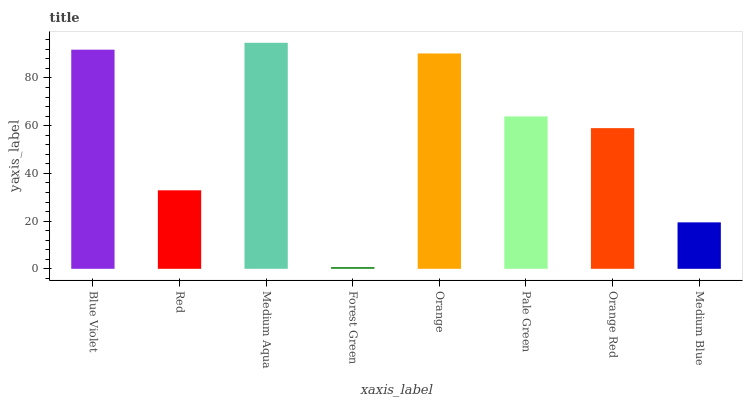Is Forest Green the minimum?
Answer yes or no. Yes. Is Medium Aqua the maximum?
Answer yes or no. Yes. Is Red the minimum?
Answer yes or no. No. Is Red the maximum?
Answer yes or no. No. Is Blue Violet greater than Red?
Answer yes or no. Yes. Is Red less than Blue Violet?
Answer yes or no. Yes. Is Red greater than Blue Violet?
Answer yes or no. No. Is Blue Violet less than Red?
Answer yes or no. No. Is Pale Green the high median?
Answer yes or no. Yes. Is Orange Red the low median?
Answer yes or no. Yes. Is Orange the high median?
Answer yes or no. No. Is Medium Blue the low median?
Answer yes or no. No. 